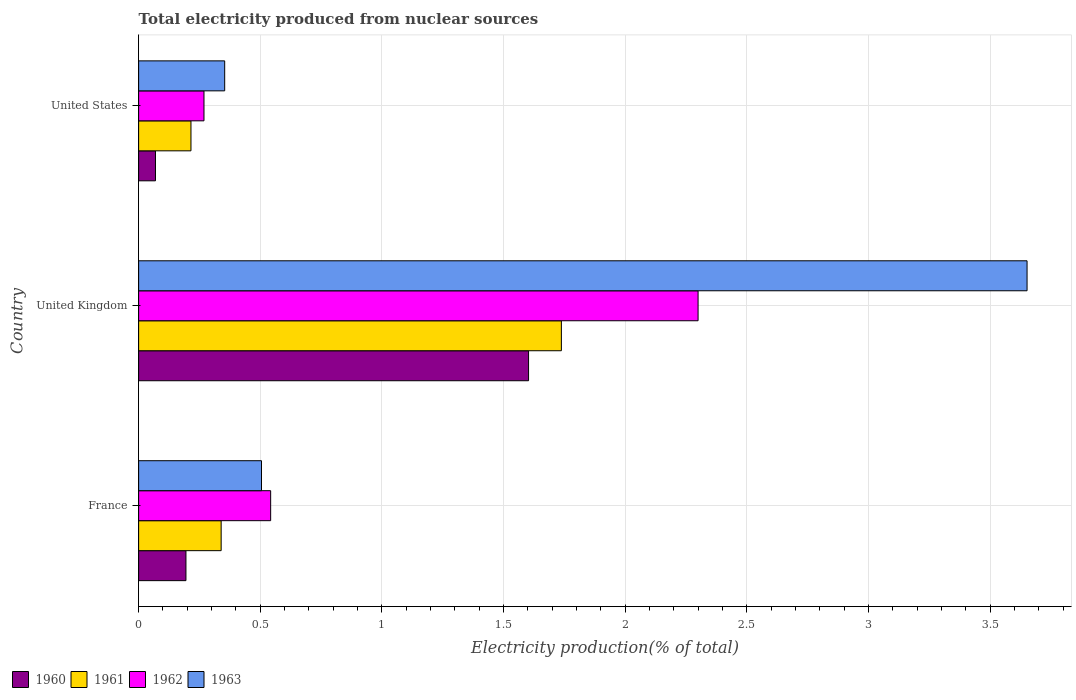How many groups of bars are there?
Keep it short and to the point. 3. Are the number of bars per tick equal to the number of legend labels?
Offer a terse response. Yes. Are the number of bars on each tick of the Y-axis equal?
Your answer should be very brief. Yes. How many bars are there on the 2nd tick from the top?
Your answer should be compact. 4. What is the total electricity produced in 1960 in France?
Offer a very short reply. 0.19. Across all countries, what is the maximum total electricity produced in 1961?
Offer a terse response. 1.74. Across all countries, what is the minimum total electricity produced in 1963?
Make the answer very short. 0.35. In which country was the total electricity produced in 1961 maximum?
Keep it short and to the point. United Kingdom. In which country was the total electricity produced in 1960 minimum?
Your response must be concise. United States. What is the total total electricity produced in 1961 in the graph?
Your answer should be compact. 2.29. What is the difference between the total electricity produced in 1963 in United Kingdom and that in United States?
Provide a succinct answer. 3.3. What is the difference between the total electricity produced in 1962 in France and the total electricity produced in 1963 in United Kingdom?
Ensure brevity in your answer.  -3.11. What is the average total electricity produced in 1960 per country?
Your answer should be compact. 0.62. What is the difference between the total electricity produced in 1960 and total electricity produced in 1962 in United States?
Ensure brevity in your answer.  -0.2. In how many countries, is the total electricity produced in 1963 greater than 2 %?
Make the answer very short. 1. What is the ratio of the total electricity produced in 1961 in United Kingdom to that in United States?
Provide a succinct answer. 8.08. Is the difference between the total electricity produced in 1960 in United Kingdom and United States greater than the difference between the total electricity produced in 1962 in United Kingdom and United States?
Your answer should be compact. No. What is the difference between the highest and the second highest total electricity produced in 1963?
Make the answer very short. 3.15. What is the difference between the highest and the lowest total electricity produced in 1963?
Keep it short and to the point. 3.3. Is the sum of the total electricity produced in 1962 in France and United States greater than the maximum total electricity produced in 1961 across all countries?
Keep it short and to the point. No. Is it the case that in every country, the sum of the total electricity produced in 1963 and total electricity produced in 1962 is greater than the sum of total electricity produced in 1961 and total electricity produced in 1960?
Offer a terse response. No. What does the 2nd bar from the bottom in France represents?
Ensure brevity in your answer.  1961. Is it the case that in every country, the sum of the total electricity produced in 1963 and total electricity produced in 1962 is greater than the total electricity produced in 1961?
Offer a terse response. Yes. How many bars are there?
Make the answer very short. 12. Are all the bars in the graph horizontal?
Your answer should be compact. Yes. Are the values on the major ticks of X-axis written in scientific E-notation?
Give a very brief answer. No. Does the graph contain grids?
Ensure brevity in your answer.  Yes. Where does the legend appear in the graph?
Provide a short and direct response. Bottom left. How are the legend labels stacked?
Your answer should be compact. Horizontal. What is the title of the graph?
Your answer should be very brief. Total electricity produced from nuclear sources. What is the label or title of the X-axis?
Provide a succinct answer. Electricity production(% of total). What is the Electricity production(% of total) of 1960 in France?
Give a very brief answer. 0.19. What is the Electricity production(% of total) of 1961 in France?
Give a very brief answer. 0.34. What is the Electricity production(% of total) in 1962 in France?
Offer a very short reply. 0.54. What is the Electricity production(% of total) of 1963 in France?
Your answer should be very brief. 0.51. What is the Electricity production(% of total) in 1960 in United Kingdom?
Provide a short and direct response. 1.6. What is the Electricity production(% of total) of 1961 in United Kingdom?
Offer a terse response. 1.74. What is the Electricity production(% of total) of 1962 in United Kingdom?
Keep it short and to the point. 2.3. What is the Electricity production(% of total) of 1963 in United Kingdom?
Make the answer very short. 3.65. What is the Electricity production(% of total) in 1960 in United States?
Give a very brief answer. 0.07. What is the Electricity production(% of total) of 1961 in United States?
Ensure brevity in your answer.  0.22. What is the Electricity production(% of total) of 1962 in United States?
Provide a short and direct response. 0.27. What is the Electricity production(% of total) of 1963 in United States?
Provide a short and direct response. 0.35. Across all countries, what is the maximum Electricity production(% of total) of 1960?
Your answer should be compact. 1.6. Across all countries, what is the maximum Electricity production(% of total) of 1961?
Provide a succinct answer. 1.74. Across all countries, what is the maximum Electricity production(% of total) in 1962?
Offer a very short reply. 2.3. Across all countries, what is the maximum Electricity production(% of total) in 1963?
Your answer should be very brief. 3.65. Across all countries, what is the minimum Electricity production(% of total) of 1960?
Make the answer very short. 0.07. Across all countries, what is the minimum Electricity production(% of total) of 1961?
Make the answer very short. 0.22. Across all countries, what is the minimum Electricity production(% of total) of 1962?
Offer a very short reply. 0.27. Across all countries, what is the minimum Electricity production(% of total) in 1963?
Offer a very short reply. 0.35. What is the total Electricity production(% of total) in 1960 in the graph?
Make the answer very short. 1.87. What is the total Electricity production(% of total) of 1961 in the graph?
Your response must be concise. 2.29. What is the total Electricity production(% of total) of 1962 in the graph?
Provide a short and direct response. 3.11. What is the total Electricity production(% of total) in 1963 in the graph?
Provide a short and direct response. 4.51. What is the difference between the Electricity production(% of total) in 1960 in France and that in United Kingdom?
Provide a short and direct response. -1.41. What is the difference between the Electricity production(% of total) in 1961 in France and that in United Kingdom?
Give a very brief answer. -1.4. What is the difference between the Electricity production(% of total) in 1962 in France and that in United Kingdom?
Offer a terse response. -1.76. What is the difference between the Electricity production(% of total) in 1963 in France and that in United Kingdom?
Provide a short and direct response. -3.15. What is the difference between the Electricity production(% of total) in 1960 in France and that in United States?
Provide a succinct answer. 0.13. What is the difference between the Electricity production(% of total) of 1961 in France and that in United States?
Provide a succinct answer. 0.12. What is the difference between the Electricity production(% of total) in 1962 in France and that in United States?
Your answer should be compact. 0.27. What is the difference between the Electricity production(% of total) of 1963 in France and that in United States?
Your response must be concise. 0.15. What is the difference between the Electricity production(% of total) in 1960 in United Kingdom and that in United States?
Make the answer very short. 1.53. What is the difference between the Electricity production(% of total) in 1961 in United Kingdom and that in United States?
Your answer should be very brief. 1.52. What is the difference between the Electricity production(% of total) in 1962 in United Kingdom and that in United States?
Offer a terse response. 2.03. What is the difference between the Electricity production(% of total) in 1963 in United Kingdom and that in United States?
Your answer should be very brief. 3.3. What is the difference between the Electricity production(% of total) in 1960 in France and the Electricity production(% of total) in 1961 in United Kingdom?
Your answer should be compact. -1.54. What is the difference between the Electricity production(% of total) of 1960 in France and the Electricity production(% of total) of 1962 in United Kingdom?
Give a very brief answer. -2.11. What is the difference between the Electricity production(% of total) in 1960 in France and the Electricity production(% of total) in 1963 in United Kingdom?
Make the answer very short. -3.46. What is the difference between the Electricity production(% of total) of 1961 in France and the Electricity production(% of total) of 1962 in United Kingdom?
Give a very brief answer. -1.96. What is the difference between the Electricity production(% of total) in 1961 in France and the Electricity production(% of total) in 1963 in United Kingdom?
Your answer should be compact. -3.31. What is the difference between the Electricity production(% of total) in 1962 in France and the Electricity production(% of total) in 1963 in United Kingdom?
Your answer should be compact. -3.11. What is the difference between the Electricity production(% of total) in 1960 in France and the Electricity production(% of total) in 1961 in United States?
Your response must be concise. -0.02. What is the difference between the Electricity production(% of total) in 1960 in France and the Electricity production(% of total) in 1962 in United States?
Give a very brief answer. -0.07. What is the difference between the Electricity production(% of total) in 1960 in France and the Electricity production(% of total) in 1963 in United States?
Provide a succinct answer. -0.16. What is the difference between the Electricity production(% of total) in 1961 in France and the Electricity production(% of total) in 1962 in United States?
Offer a terse response. 0.07. What is the difference between the Electricity production(% of total) in 1961 in France and the Electricity production(% of total) in 1963 in United States?
Your answer should be very brief. -0.01. What is the difference between the Electricity production(% of total) in 1962 in France and the Electricity production(% of total) in 1963 in United States?
Make the answer very short. 0.19. What is the difference between the Electricity production(% of total) in 1960 in United Kingdom and the Electricity production(% of total) in 1961 in United States?
Offer a very short reply. 1.39. What is the difference between the Electricity production(% of total) of 1960 in United Kingdom and the Electricity production(% of total) of 1962 in United States?
Your answer should be compact. 1.33. What is the difference between the Electricity production(% of total) in 1960 in United Kingdom and the Electricity production(% of total) in 1963 in United States?
Your answer should be very brief. 1.25. What is the difference between the Electricity production(% of total) in 1961 in United Kingdom and the Electricity production(% of total) in 1962 in United States?
Your answer should be compact. 1.47. What is the difference between the Electricity production(% of total) of 1961 in United Kingdom and the Electricity production(% of total) of 1963 in United States?
Ensure brevity in your answer.  1.38. What is the difference between the Electricity production(% of total) of 1962 in United Kingdom and the Electricity production(% of total) of 1963 in United States?
Your response must be concise. 1.95. What is the average Electricity production(% of total) in 1960 per country?
Give a very brief answer. 0.62. What is the average Electricity production(% of total) in 1961 per country?
Your response must be concise. 0.76. What is the average Electricity production(% of total) in 1963 per country?
Your response must be concise. 1.5. What is the difference between the Electricity production(% of total) in 1960 and Electricity production(% of total) in 1961 in France?
Provide a short and direct response. -0.14. What is the difference between the Electricity production(% of total) of 1960 and Electricity production(% of total) of 1962 in France?
Your answer should be compact. -0.35. What is the difference between the Electricity production(% of total) in 1960 and Electricity production(% of total) in 1963 in France?
Your answer should be compact. -0.31. What is the difference between the Electricity production(% of total) of 1961 and Electricity production(% of total) of 1962 in France?
Provide a short and direct response. -0.2. What is the difference between the Electricity production(% of total) in 1961 and Electricity production(% of total) in 1963 in France?
Keep it short and to the point. -0.17. What is the difference between the Electricity production(% of total) of 1962 and Electricity production(% of total) of 1963 in France?
Provide a succinct answer. 0.04. What is the difference between the Electricity production(% of total) in 1960 and Electricity production(% of total) in 1961 in United Kingdom?
Make the answer very short. -0.13. What is the difference between the Electricity production(% of total) of 1960 and Electricity production(% of total) of 1962 in United Kingdom?
Make the answer very short. -0.7. What is the difference between the Electricity production(% of total) of 1960 and Electricity production(% of total) of 1963 in United Kingdom?
Offer a terse response. -2.05. What is the difference between the Electricity production(% of total) in 1961 and Electricity production(% of total) in 1962 in United Kingdom?
Provide a succinct answer. -0.56. What is the difference between the Electricity production(% of total) of 1961 and Electricity production(% of total) of 1963 in United Kingdom?
Ensure brevity in your answer.  -1.91. What is the difference between the Electricity production(% of total) in 1962 and Electricity production(% of total) in 1963 in United Kingdom?
Offer a terse response. -1.35. What is the difference between the Electricity production(% of total) of 1960 and Electricity production(% of total) of 1961 in United States?
Keep it short and to the point. -0.15. What is the difference between the Electricity production(% of total) of 1960 and Electricity production(% of total) of 1962 in United States?
Your response must be concise. -0.2. What is the difference between the Electricity production(% of total) in 1960 and Electricity production(% of total) in 1963 in United States?
Offer a terse response. -0.28. What is the difference between the Electricity production(% of total) in 1961 and Electricity production(% of total) in 1962 in United States?
Ensure brevity in your answer.  -0.05. What is the difference between the Electricity production(% of total) in 1961 and Electricity production(% of total) in 1963 in United States?
Your answer should be compact. -0.14. What is the difference between the Electricity production(% of total) of 1962 and Electricity production(% of total) of 1963 in United States?
Your answer should be compact. -0.09. What is the ratio of the Electricity production(% of total) of 1960 in France to that in United Kingdom?
Your answer should be compact. 0.12. What is the ratio of the Electricity production(% of total) of 1961 in France to that in United Kingdom?
Provide a short and direct response. 0.2. What is the ratio of the Electricity production(% of total) in 1962 in France to that in United Kingdom?
Offer a terse response. 0.24. What is the ratio of the Electricity production(% of total) in 1963 in France to that in United Kingdom?
Provide a short and direct response. 0.14. What is the ratio of the Electricity production(% of total) in 1960 in France to that in United States?
Offer a terse response. 2.81. What is the ratio of the Electricity production(% of total) in 1961 in France to that in United States?
Your answer should be very brief. 1.58. What is the ratio of the Electricity production(% of total) in 1962 in France to that in United States?
Provide a short and direct response. 2.02. What is the ratio of the Electricity production(% of total) in 1963 in France to that in United States?
Offer a very short reply. 1.43. What is the ratio of the Electricity production(% of total) in 1960 in United Kingdom to that in United States?
Your answer should be compact. 23.14. What is the ratio of the Electricity production(% of total) in 1961 in United Kingdom to that in United States?
Keep it short and to the point. 8.08. What is the ratio of the Electricity production(% of total) of 1962 in United Kingdom to that in United States?
Offer a very short reply. 8.56. What is the ratio of the Electricity production(% of total) in 1963 in United Kingdom to that in United States?
Provide a short and direct response. 10.32. What is the difference between the highest and the second highest Electricity production(% of total) in 1960?
Provide a succinct answer. 1.41. What is the difference between the highest and the second highest Electricity production(% of total) of 1961?
Provide a succinct answer. 1.4. What is the difference between the highest and the second highest Electricity production(% of total) of 1962?
Provide a succinct answer. 1.76. What is the difference between the highest and the second highest Electricity production(% of total) of 1963?
Give a very brief answer. 3.15. What is the difference between the highest and the lowest Electricity production(% of total) of 1960?
Offer a very short reply. 1.53. What is the difference between the highest and the lowest Electricity production(% of total) in 1961?
Provide a succinct answer. 1.52. What is the difference between the highest and the lowest Electricity production(% of total) in 1962?
Your answer should be compact. 2.03. What is the difference between the highest and the lowest Electricity production(% of total) of 1963?
Keep it short and to the point. 3.3. 